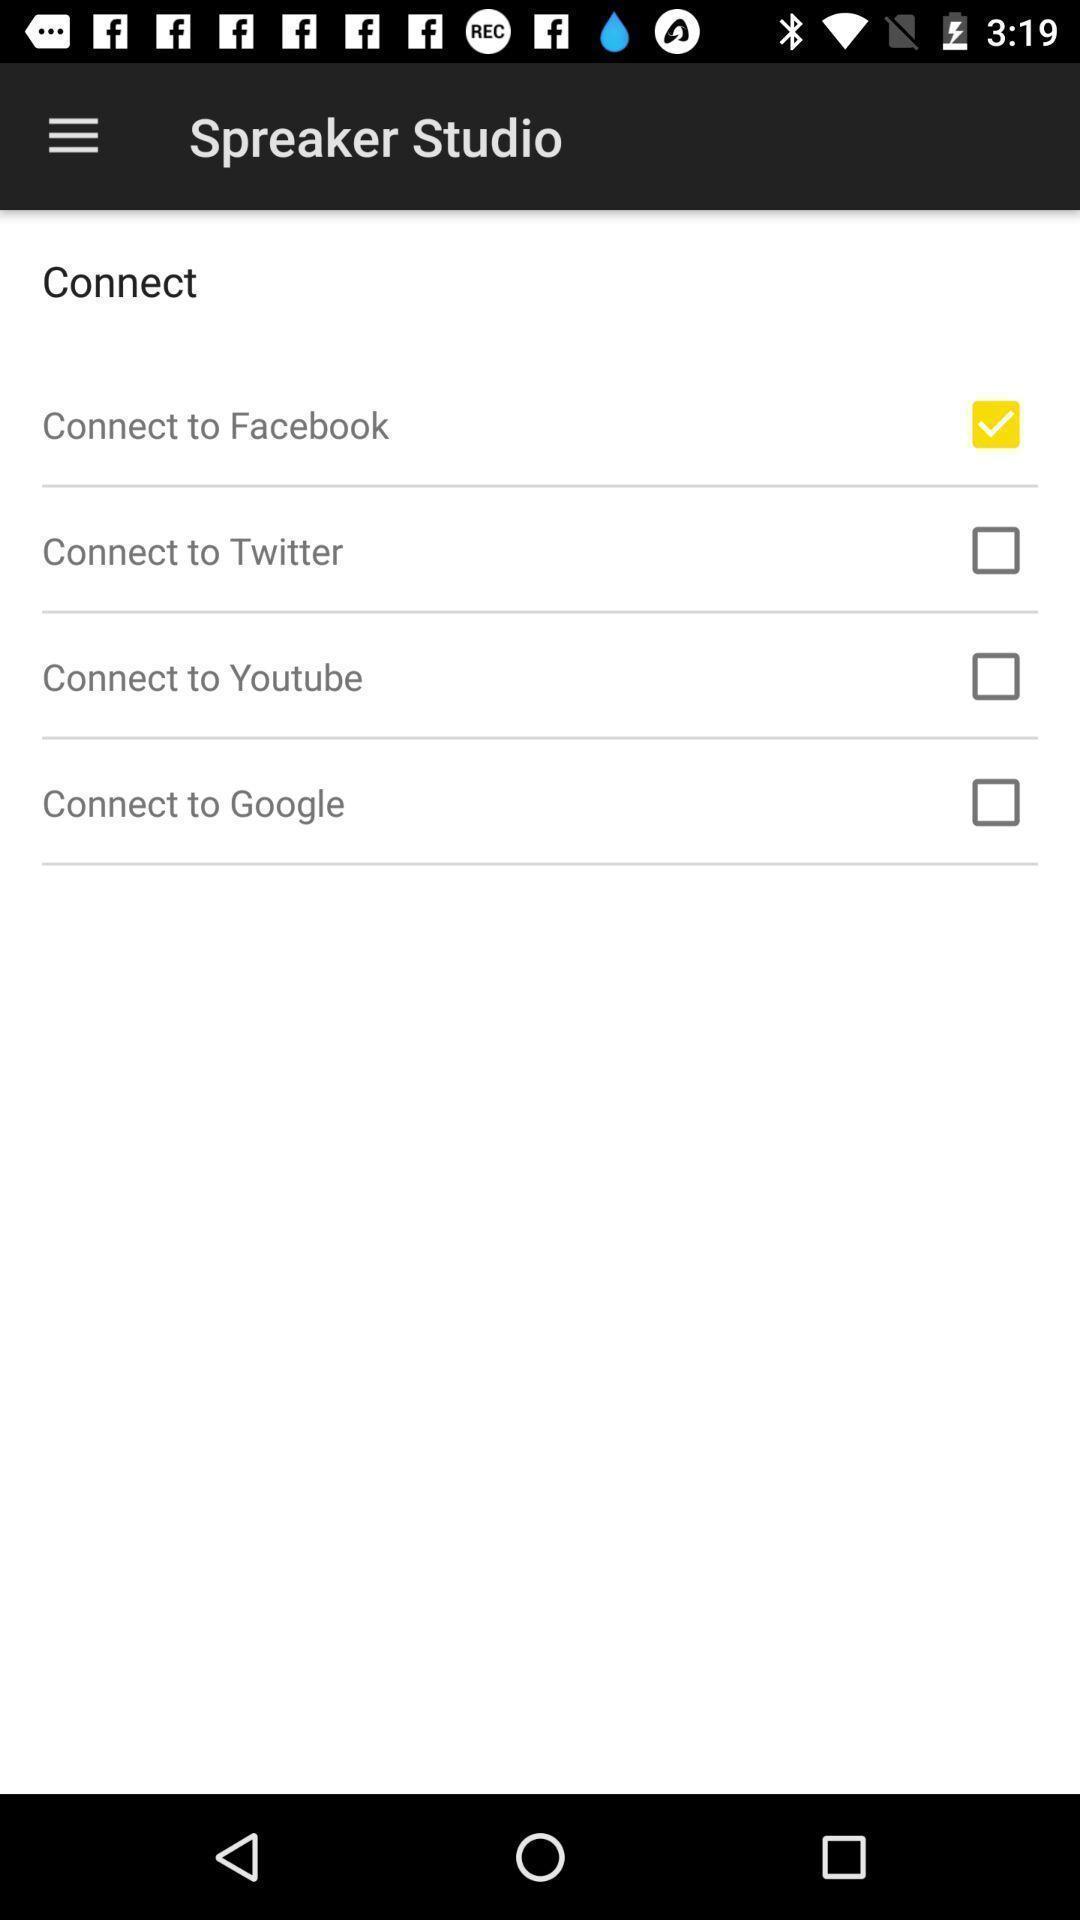Summarize the information in this screenshot. Page displaying various options in a podcast app. 